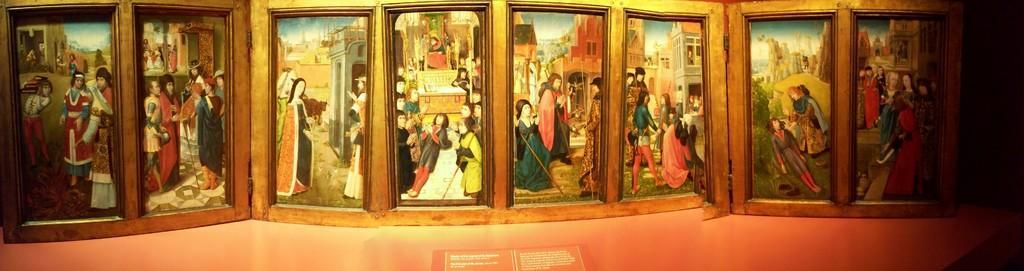How would you summarize this image in a sentence or two? Here in this picture we can see portraits present over a place. 